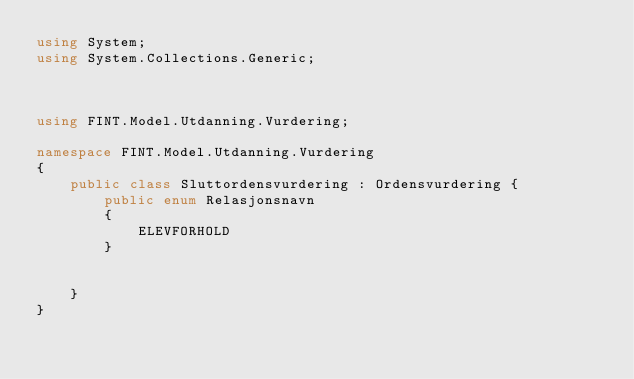Convert code to text. <code><loc_0><loc_0><loc_500><loc_500><_C#_>using System;
using System.Collections.Generic;



using FINT.Model.Utdanning.Vurdering;

namespace FINT.Model.Utdanning.Vurdering
{
	public class Sluttordensvurdering : Ordensvurdering {
		public enum Relasjonsnavn
        {
			ELEVFORHOLD
        }
        
	
	}
}
</code> 